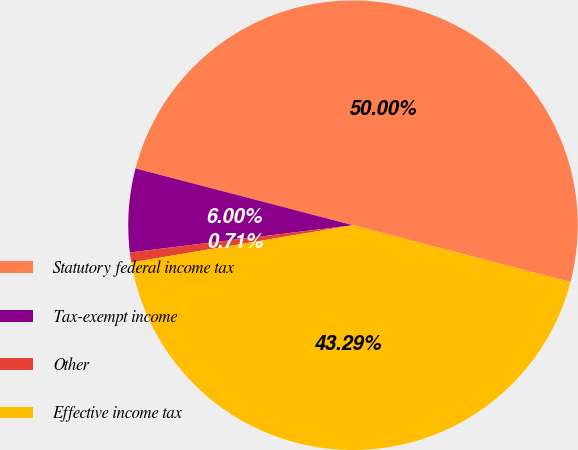Convert chart to OTSL. <chart><loc_0><loc_0><loc_500><loc_500><pie_chart><fcel>Statutory federal income tax<fcel>Tax-exempt income<fcel>Other<fcel>Effective income tax<nl><fcel>50.0%<fcel>6.0%<fcel>0.71%<fcel>43.29%<nl></chart> 